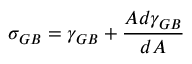<formula> <loc_0><loc_0><loc_500><loc_500>\sigma _ { G B } = \gamma _ { G B } + { \frac { A d \gamma _ { G B } } { d A } } \,</formula> 